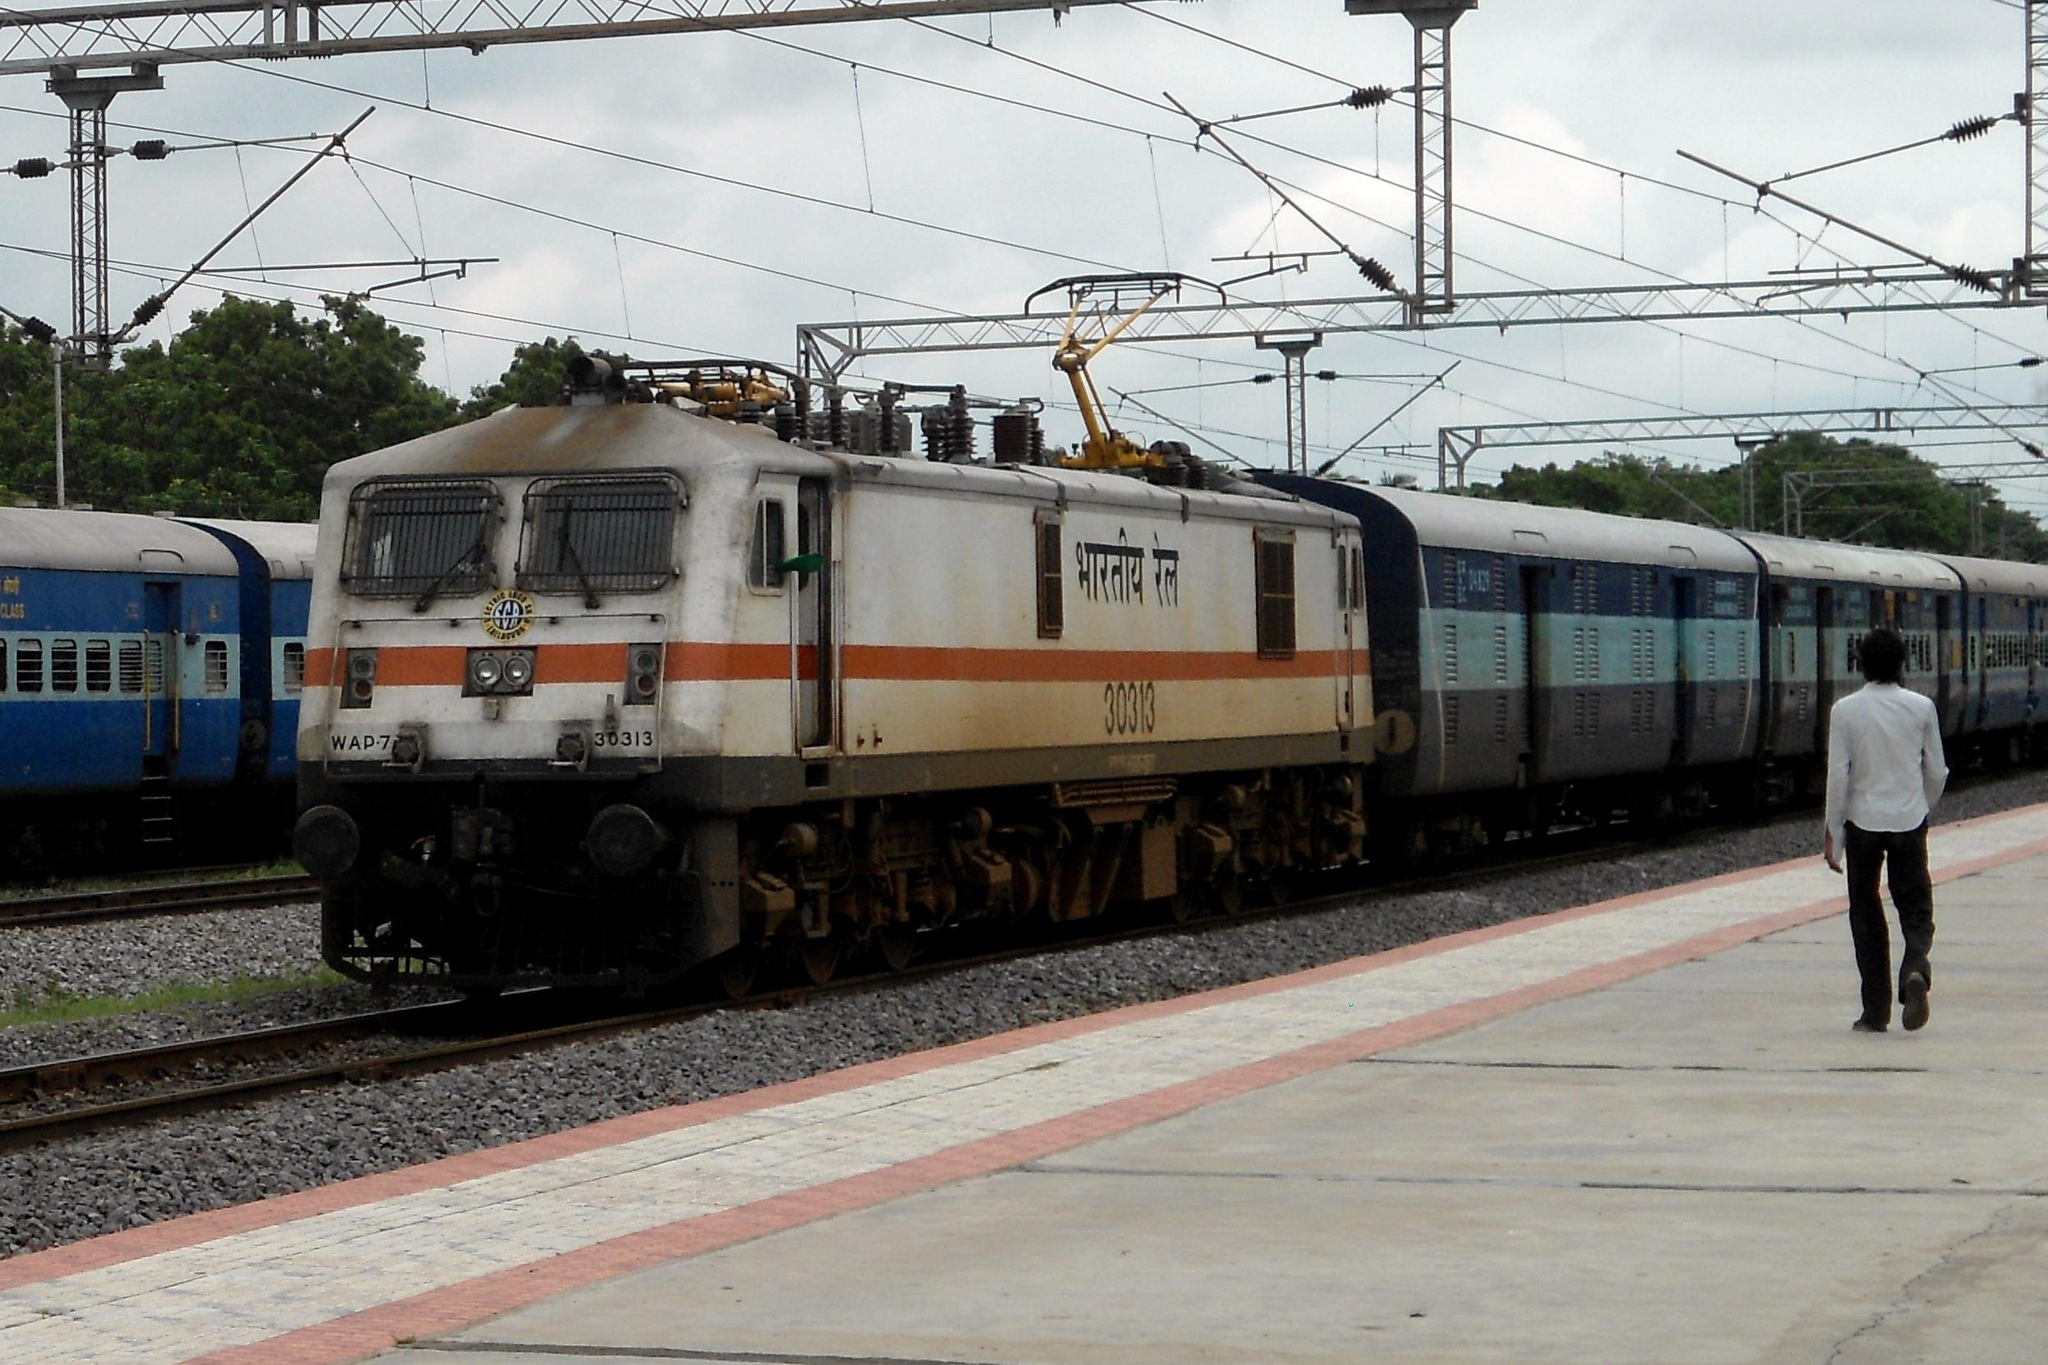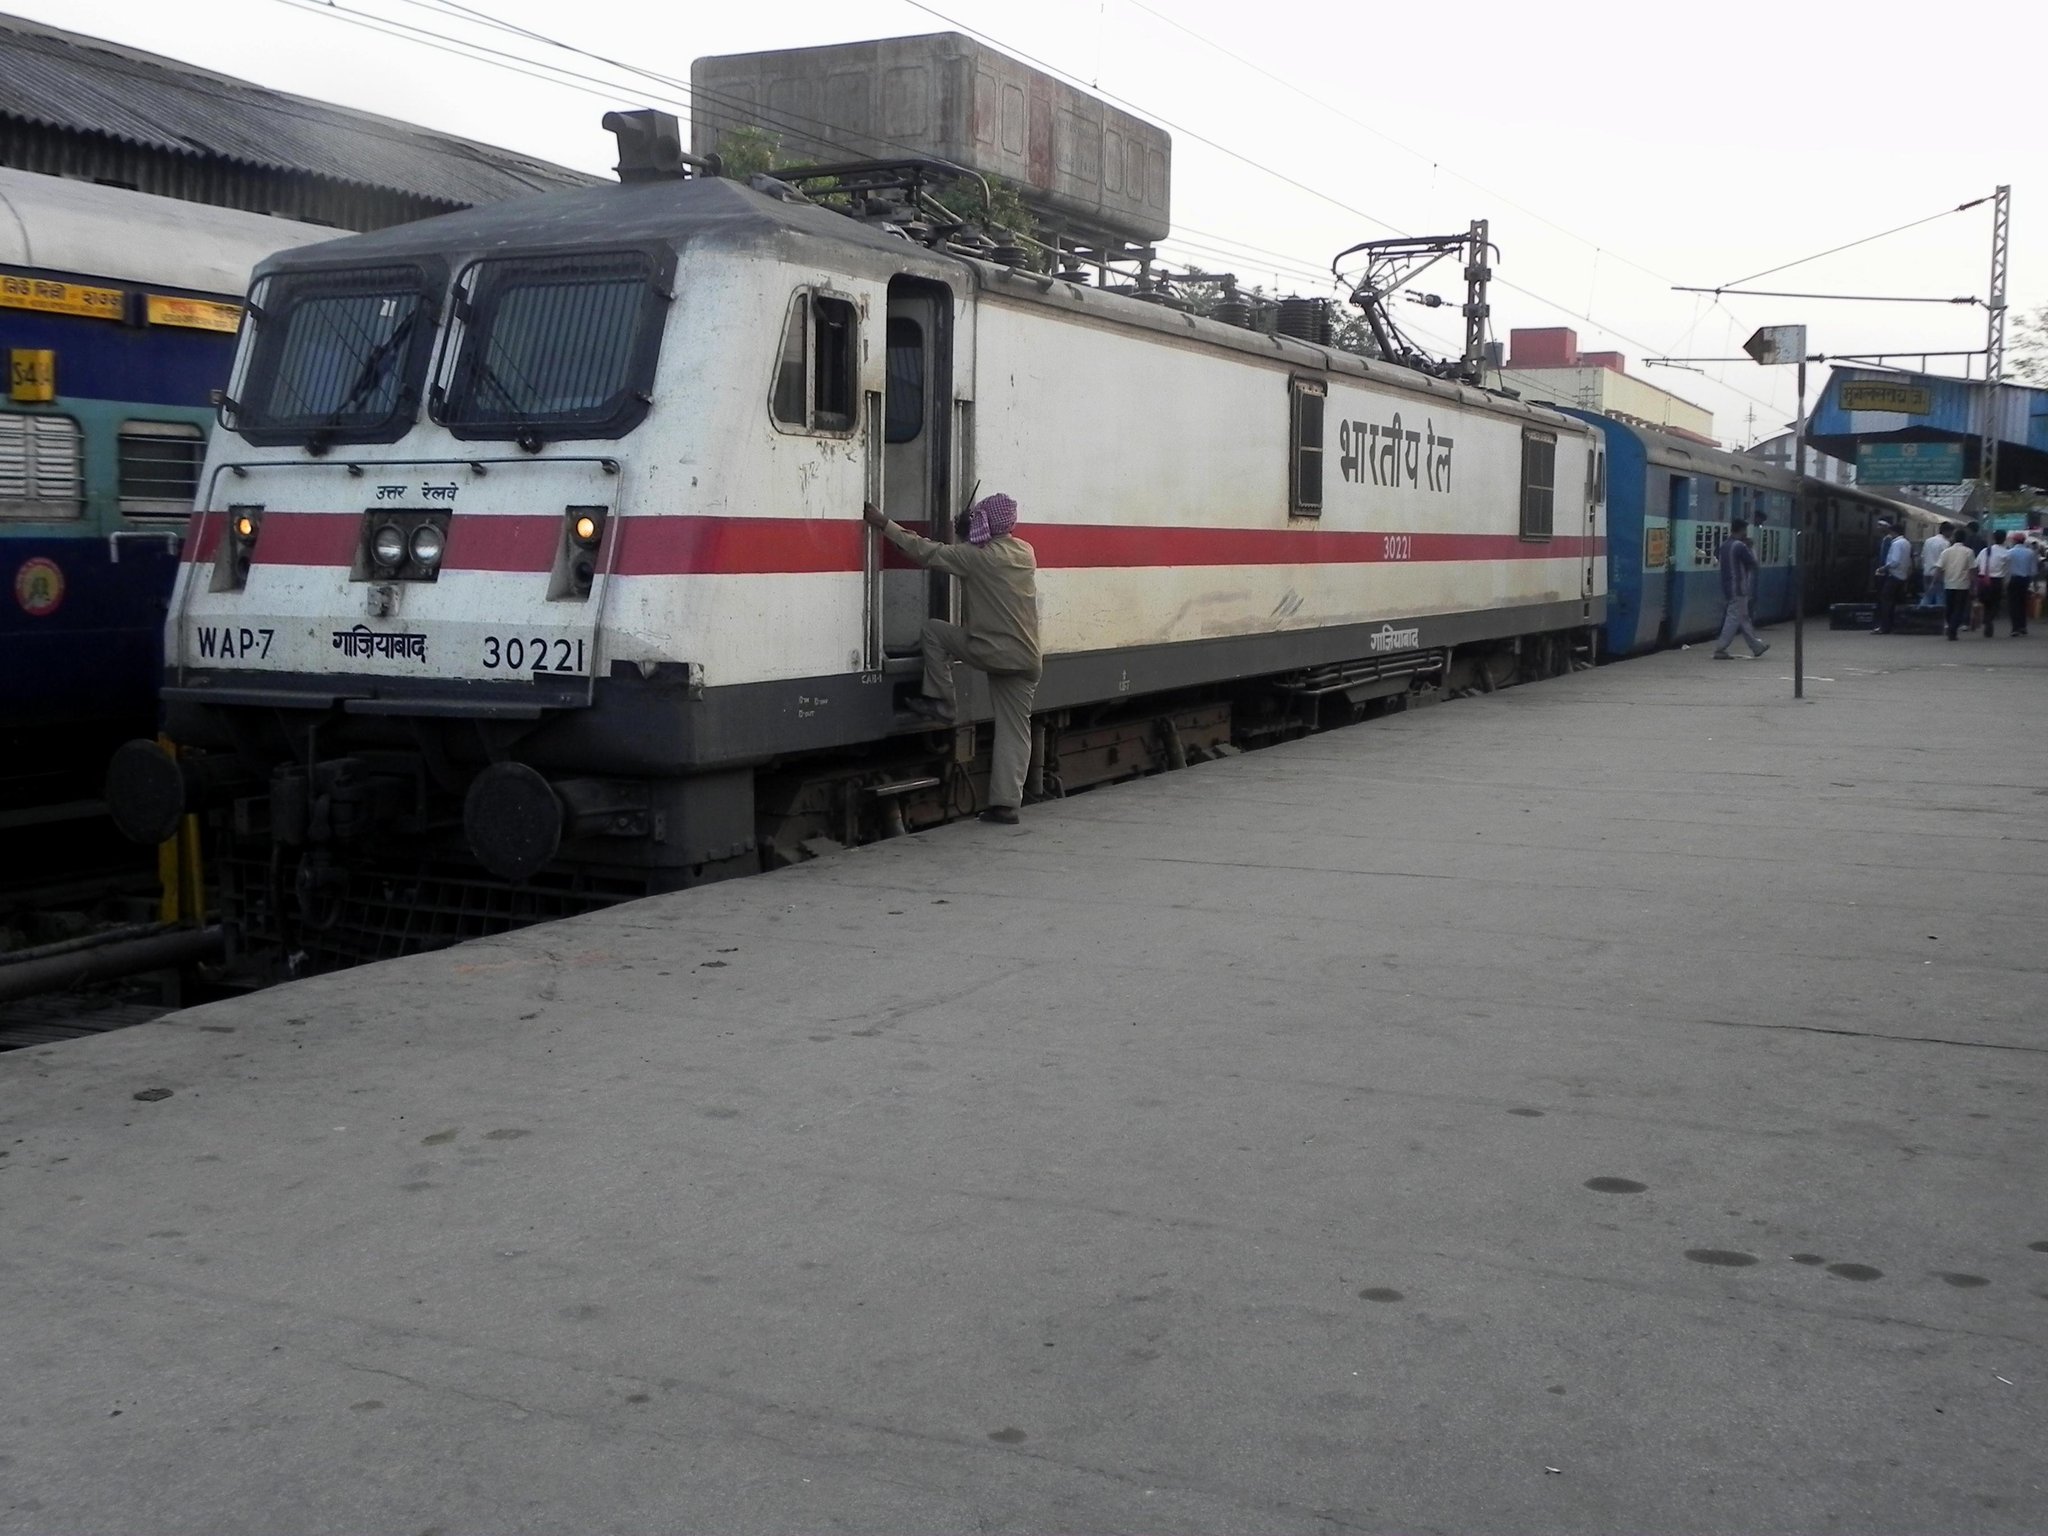The first image is the image on the left, the second image is the image on the right. Examine the images to the left and right. Is the description "Multiple people stand to one side of a train in one image, but no one is by the train in the other image, which angles rightward." accurate? Answer yes or no. No. The first image is the image on the left, the second image is the image on the right. Analyze the images presented: Is the assertion "Several people are standing on the platform near the train in the image on the left." valid? Answer yes or no. No. 